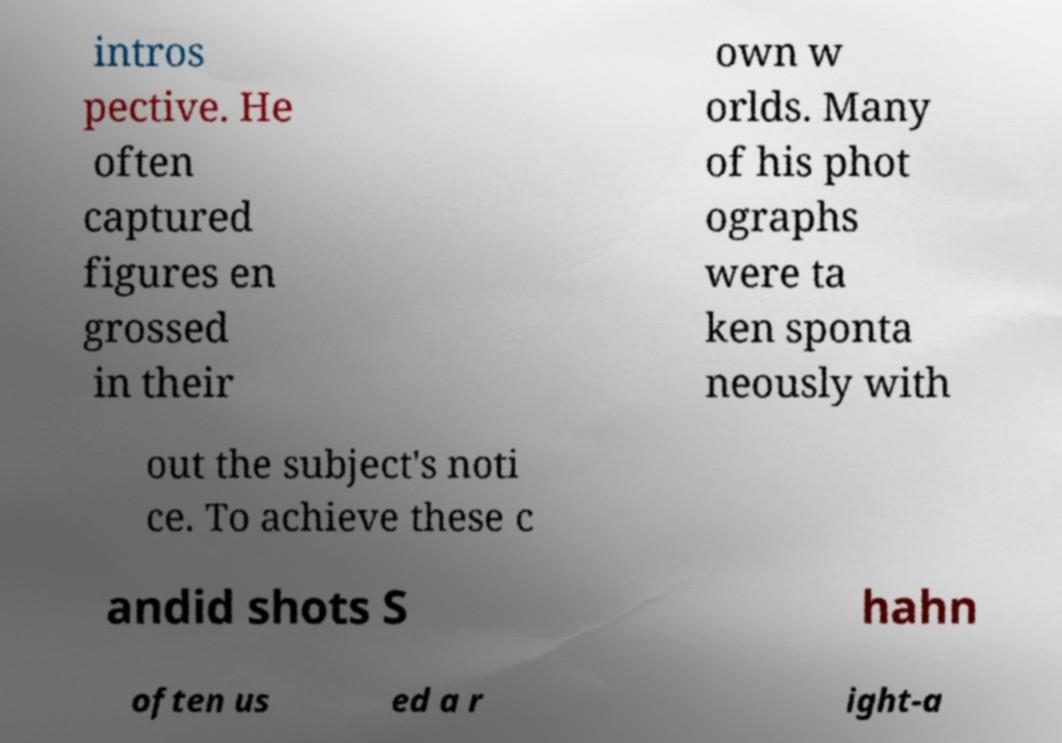Please read and relay the text visible in this image. What does it say? intros pective. He often captured figures en grossed in their own w orlds. Many of his phot ographs were ta ken sponta neously with out the subject's noti ce. To achieve these c andid shots S hahn often us ed a r ight-a 